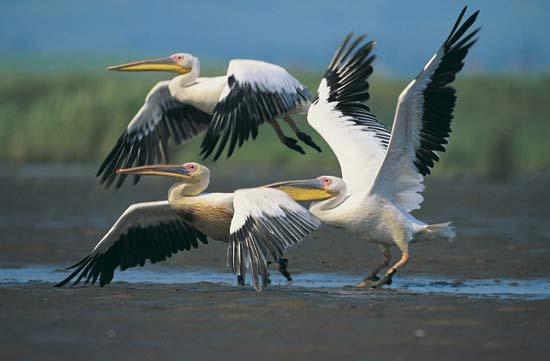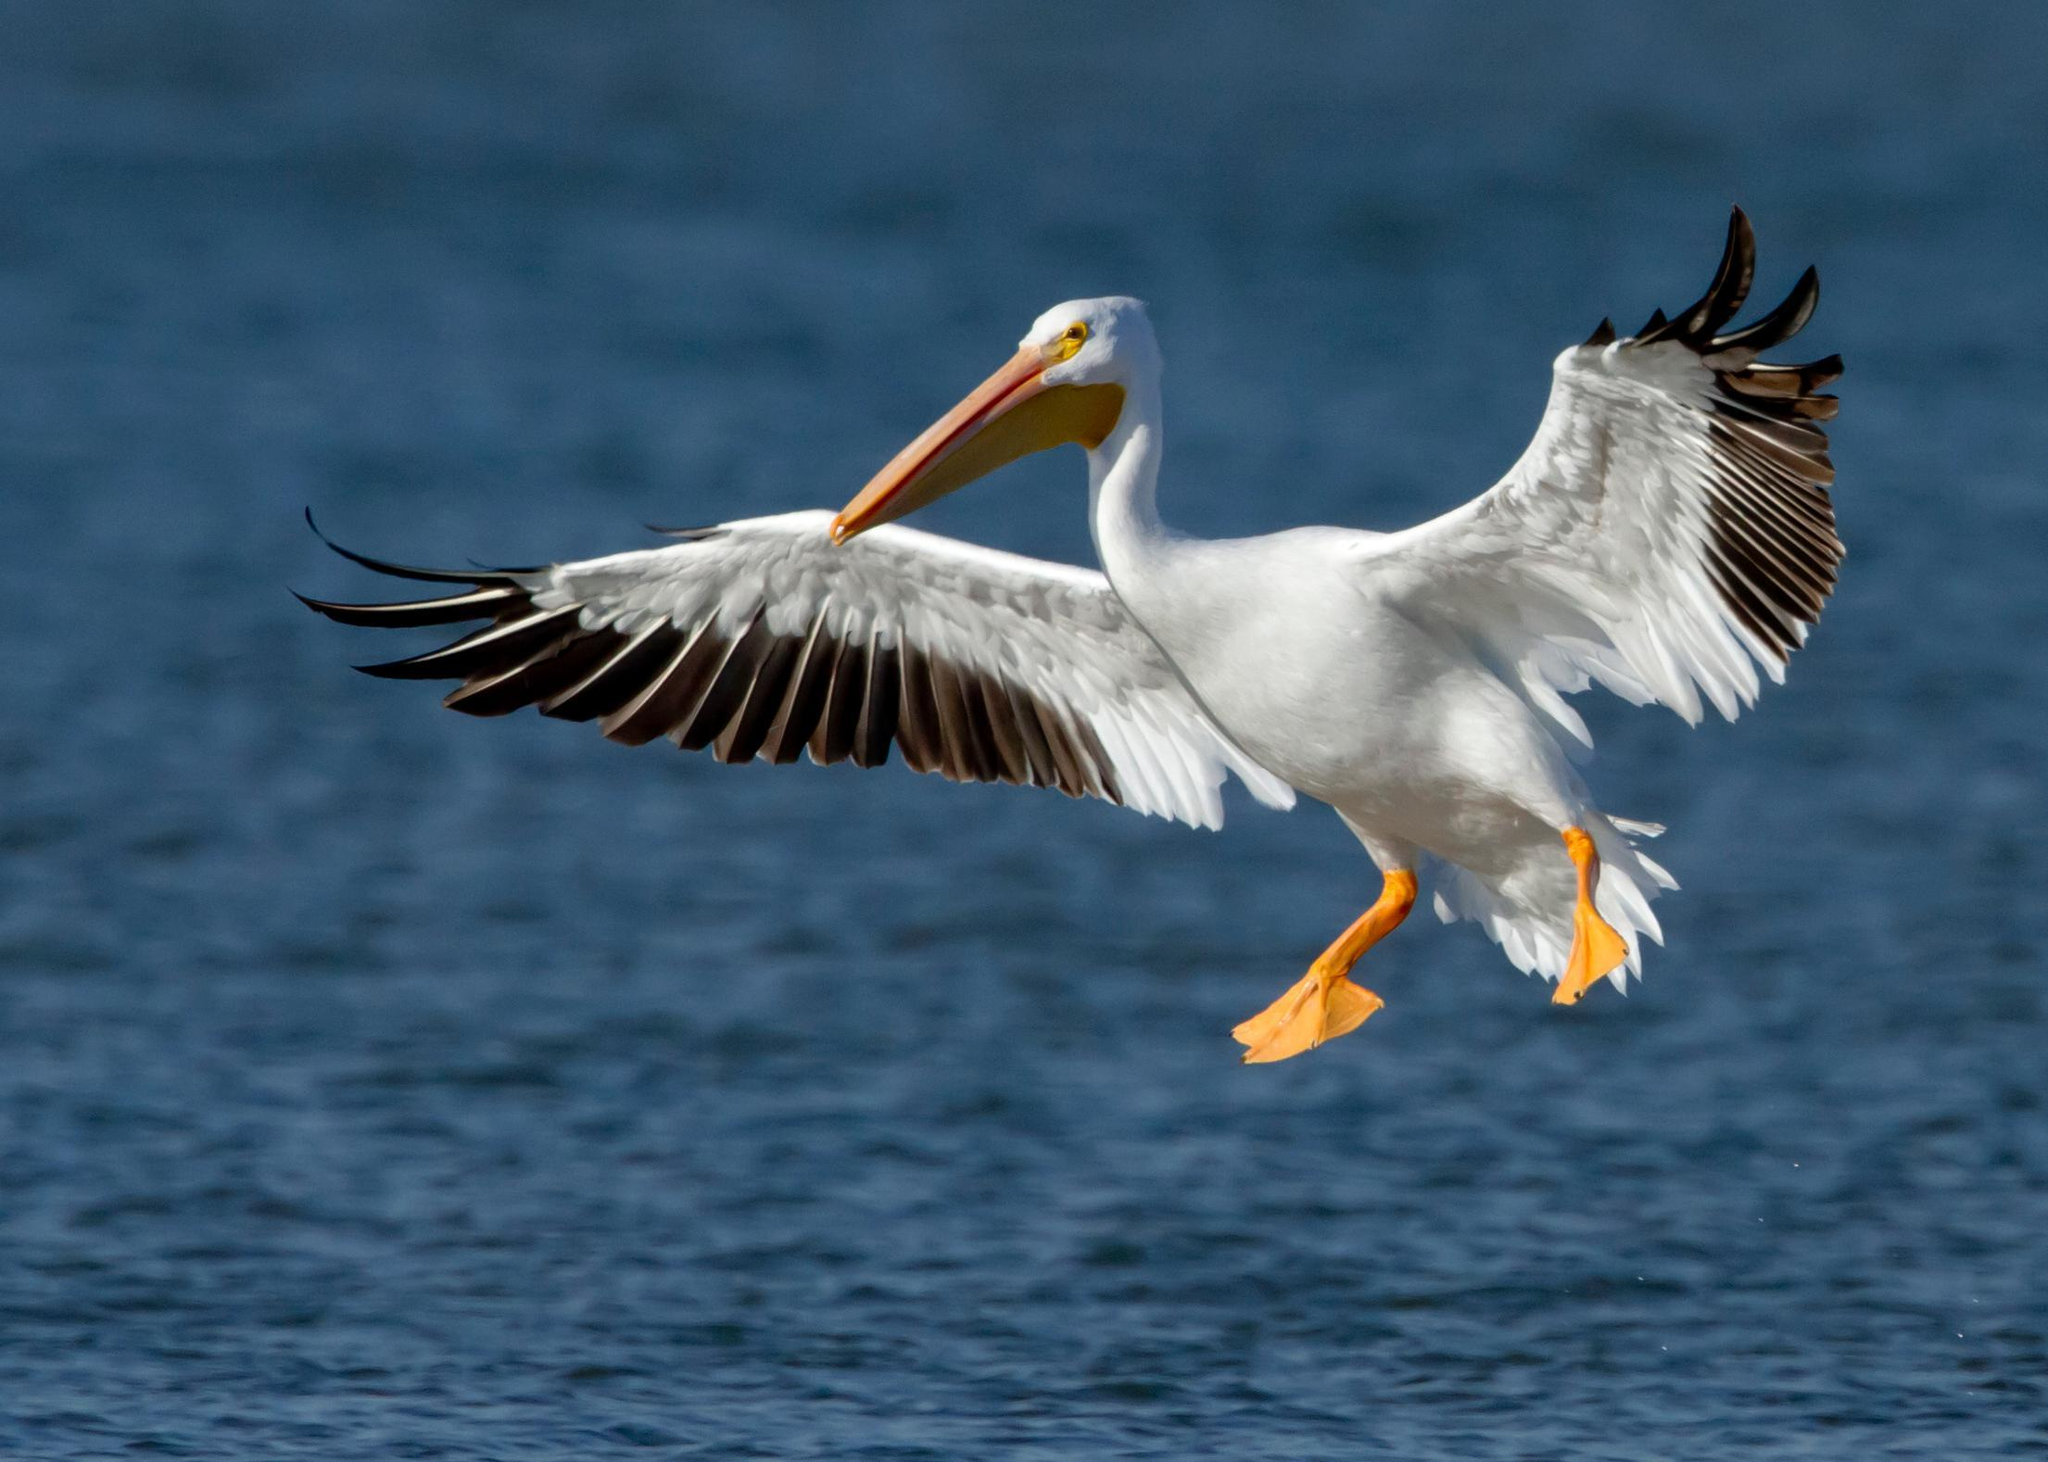The first image is the image on the left, the second image is the image on the right. Examine the images to the left and right. Is the description "There is one bird flying in the picture on the right." accurate? Answer yes or no. Yes. 